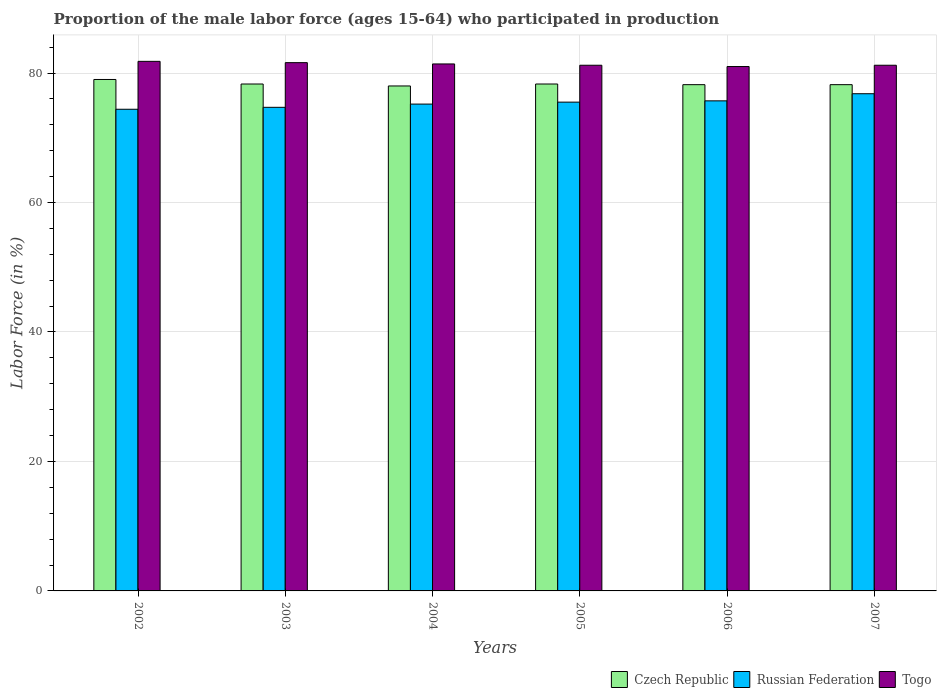How many different coloured bars are there?
Your answer should be compact. 3. Are the number of bars on each tick of the X-axis equal?
Offer a terse response. Yes. What is the label of the 3rd group of bars from the left?
Offer a very short reply. 2004. In how many cases, is the number of bars for a given year not equal to the number of legend labels?
Your answer should be very brief. 0. What is the proportion of the male labor force who participated in production in Russian Federation in 2005?
Provide a succinct answer. 75.5. Across all years, what is the maximum proportion of the male labor force who participated in production in Togo?
Offer a very short reply. 81.8. Across all years, what is the minimum proportion of the male labor force who participated in production in Russian Federation?
Keep it short and to the point. 74.4. In which year was the proportion of the male labor force who participated in production in Czech Republic minimum?
Make the answer very short. 2004. What is the total proportion of the male labor force who participated in production in Czech Republic in the graph?
Make the answer very short. 470. What is the difference between the proportion of the male labor force who participated in production in Togo in 2004 and that in 2006?
Ensure brevity in your answer.  0.4. What is the difference between the proportion of the male labor force who participated in production in Czech Republic in 2007 and the proportion of the male labor force who participated in production in Togo in 2002?
Your answer should be compact. -3.6. What is the average proportion of the male labor force who participated in production in Russian Federation per year?
Your response must be concise. 75.38. In the year 2007, what is the difference between the proportion of the male labor force who participated in production in Togo and proportion of the male labor force who participated in production in Czech Republic?
Keep it short and to the point. 3. In how many years, is the proportion of the male labor force who participated in production in Togo greater than 24 %?
Provide a short and direct response. 6. What is the ratio of the proportion of the male labor force who participated in production in Togo in 2002 to that in 2003?
Your response must be concise. 1. Is the proportion of the male labor force who participated in production in Togo in 2003 less than that in 2005?
Ensure brevity in your answer.  No. Is the difference between the proportion of the male labor force who participated in production in Togo in 2006 and 2007 greater than the difference between the proportion of the male labor force who participated in production in Czech Republic in 2006 and 2007?
Your answer should be compact. No. What is the difference between the highest and the second highest proportion of the male labor force who participated in production in Togo?
Your response must be concise. 0.2. What is the difference between the highest and the lowest proportion of the male labor force who participated in production in Russian Federation?
Your response must be concise. 2.4. In how many years, is the proportion of the male labor force who participated in production in Czech Republic greater than the average proportion of the male labor force who participated in production in Czech Republic taken over all years?
Your response must be concise. 1. What does the 2nd bar from the left in 2004 represents?
Your response must be concise. Russian Federation. What does the 1st bar from the right in 2004 represents?
Offer a terse response. Togo. How many bars are there?
Provide a succinct answer. 18. Are all the bars in the graph horizontal?
Give a very brief answer. No. How many years are there in the graph?
Offer a very short reply. 6. Are the values on the major ticks of Y-axis written in scientific E-notation?
Your response must be concise. No. Does the graph contain any zero values?
Your answer should be very brief. No. Does the graph contain grids?
Make the answer very short. Yes. What is the title of the graph?
Give a very brief answer. Proportion of the male labor force (ages 15-64) who participated in production. What is the Labor Force (in %) of Czech Republic in 2002?
Keep it short and to the point. 79. What is the Labor Force (in %) in Russian Federation in 2002?
Your answer should be compact. 74.4. What is the Labor Force (in %) of Togo in 2002?
Your answer should be very brief. 81.8. What is the Labor Force (in %) in Czech Republic in 2003?
Ensure brevity in your answer.  78.3. What is the Labor Force (in %) in Russian Federation in 2003?
Offer a very short reply. 74.7. What is the Labor Force (in %) of Togo in 2003?
Offer a terse response. 81.6. What is the Labor Force (in %) in Russian Federation in 2004?
Your response must be concise. 75.2. What is the Labor Force (in %) in Togo in 2004?
Provide a succinct answer. 81.4. What is the Labor Force (in %) of Czech Republic in 2005?
Your answer should be compact. 78.3. What is the Labor Force (in %) in Russian Federation in 2005?
Offer a very short reply. 75.5. What is the Labor Force (in %) in Togo in 2005?
Ensure brevity in your answer.  81.2. What is the Labor Force (in %) in Czech Republic in 2006?
Your response must be concise. 78.2. What is the Labor Force (in %) in Russian Federation in 2006?
Your answer should be very brief. 75.7. What is the Labor Force (in %) of Czech Republic in 2007?
Provide a succinct answer. 78.2. What is the Labor Force (in %) of Russian Federation in 2007?
Your answer should be very brief. 76.8. What is the Labor Force (in %) in Togo in 2007?
Your response must be concise. 81.2. Across all years, what is the maximum Labor Force (in %) in Czech Republic?
Your response must be concise. 79. Across all years, what is the maximum Labor Force (in %) in Russian Federation?
Provide a succinct answer. 76.8. Across all years, what is the maximum Labor Force (in %) in Togo?
Provide a short and direct response. 81.8. Across all years, what is the minimum Labor Force (in %) of Russian Federation?
Keep it short and to the point. 74.4. Across all years, what is the minimum Labor Force (in %) of Togo?
Keep it short and to the point. 81. What is the total Labor Force (in %) of Czech Republic in the graph?
Provide a short and direct response. 470. What is the total Labor Force (in %) in Russian Federation in the graph?
Make the answer very short. 452.3. What is the total Labor Force (in %) of Togo in the graph?
Your answer should be very brief. 488.2. What is the difference between the Labor Force (in %) of Togo in 2002 and that in 2003?
Provide a short and direct response. 0.2. What is the difference between the Labor Force (in %) of Czech Republic in 2002 and that in 2004?
Your answer should be compact. 1. What is the difference between the Labor Force (in %) in Togo in 2002 and that in 2004?
Make the answer very short. 0.4. What is the difference between the Labor Force (in %) of Russian Federation in 2002 and that in 2005?
Ensure brevity in your answer.  -1.1. What is the difference between the Labor Force (in %) of Togo in 2002 and that in 2005?
Provide a short and direct response. 0.6. What is the difference between the Labor Force (in %) of Czech Republic in 2002 and that in 2006?
Make the answer very short. 0.8. What is the difference between the Labor Force (in %) of Russian Federation in 2002 and that in 2007?
Your answer should be compact. -2.4. What is the difference between the Labor Force (in %) of Togo in 2002 and that in 2007?
Your answer should be compact. 0.6. What is the difference between the Labor Force (in %) in Czech Republic in 2003 and that in 2005?
Your answer should be very brief. 0. What is the difference between the Labor Force (in %) of Togo in 2003 and that in 2005?
Your answer should be compact. 0.4. What is the difference between the Labor Force (in %) in Togo in 2003 and that in 2006?
Offer a terse response. 0.6. What is the difference between the Labor Force (in %) in Czech Republic in 2003 and that in 2007?
Provide a succinct answer. 0.1. What is the difference between the Labor Force (in %) in Togo in 2004 and that in 2005?
Offer a terse response. 0.2. What is the difference between the Labor Force (in %) in Togo in 2004 and that in 2006?
Keep it short and to the point. 0.4. What is the difference between the Labor Force (in %) of Russian Federation in 2004 and that in 2007?
Give a very brief answer. -1.6. What is the difference between the Labor Force (in %) of Czech Republic in 2005 and that in 2006?
Offer a terse response. 0.1. What is the difference between the Labor Force (in %) in Russian Federation in 2005 and that in 2006?
Keep it short and to the point. -0.2. What is the difference between the Labor Force (in %) of Togo in 2005 and that in 2006?
Make the answer very short. 0.2. What is the difference between the Labor Force (in %) in Czech Republic in 2005 and that in 2007?
Provide a succinct answer. 0.1. What is the difference between the Labor Force (in %) in Russian Federation in 2005 and that in 2007?
Make the answer very short. -1.3. What is the difference between the Labor Force (in %) in Czech Republic in 2006 and that in 2007?
Provide a succinct answer. 0. What is the difference between the Labor Force (in %) of Russian Federation in 2006 and that in 2007?
Provide a short and direct response. -1.1. What is the difference between the Labor Force (in %) in Togo in 2006 and that in 2007?
Provide a succinct answer. -0.2. What is the difference between the Labor Force (in %) in Czech Republic in 2002 and the Labor Force (in %) in Russian Federation in 2003?
Offer a terse response. 4.3. What is the difference between the Labor Force (in %) in Czech Republic in 2002 and the Labor Force (in %) in Togo in 2003?
Offer a very short reply. -2.6. What is the difference between the Labor Force (in %) in Russian Federation in 2002 and the Labor Force (in %) in Togo in 2003?
Make the answer very short. -7.2. What is the difference between the Labor Force (in %) of Czech Republic in 2002 and the Labor Force (in %) of Russian Federation in 2004?
Make the answer very short. 3.8. What is the difference between the Labor Force (in %) of Russian Federation in 2002 and the Labor Force (in %) of Togo in 2007?
Give a very brief answer. -6.8. What is the difference between the Labor Force (in %) in Russian Federation in 2003 and the Labor Force (in %) in Togo in 2004?
Offer a terse response. -6.7. What is the difference between the Labor Force (in %) of Czech Republic in 2003 and the Labor Force (in %) of Togo in 2005?
Make the answer very short. -2.9. What is the difference between the Labor Force (in %) in Czech Republic in 2003 and the Labor Force (in %) in Russian Federation in 2006?
Offer a terse response. 2.6. What is the difference between the Labor Force (in %) of Russian Federation in 2003 and the Labor Force (in %) of Togo in 2006?
Your answer should be very brief. -6.3. What is the difference between the Labor Force (in %) in Czech Republic in 2003 and the Labor Force (in %) in Russian Federation in 2007?
Your response must be concise. 1.5. What is the difference between the Labor Force (in %) of Russian Federation in 2003 and the Labor Force (in %) of Togo in 2007?
Give a very brief answer. -6.5. What is the difference between the Labor Force (in %) in Czech Republic in 2004 and the Labor Force (in %) in Russian Federation in 2005?
Make the answer very short. 2.5. What is the difference between the Labor Force (in %) of Czech Republic in 2004 and the Labor Force (in %) of Russian Federation in 2006?
Your answer should be compact. 2.3. What is the difference between the Labor Force (in %) of Russian Federation in 2004 and the Labor Force (in %) of Togo in 2006?
Give a very brief answer. -5.8. What is the difference between the Labor Force (in %) of Czech Republic in 2004 and the Labor Force (in %) of Russian Federation in 2007?
Keep it short and to the point. 1.2. What is the difference between the Labor Force (in %) in Czech Republic in 2005 and the Labor Force (in %) in Togo in 2006?
Your response must be concise. -2.7. What is the difference between the Labor Force (in %) in Russian Federation in 2005 and the Labor Force (in %) in Togo in 2006?
Your answer should be very brief. -5.5. What is the difference between the Labor Force (in %) in Czech Republic in 2005 and the Labor Force (in %) in Russian Federation in 2007?
Offer a very short reply. 1.5. What is the difference between the Labor Force (in %) of Russian Federation in 2006 and the Labor Force (in %) of Togo in 2007?
Your response must be concise. -5.5. What is the average Labor Force (in %) of Czech Republic per year?
Your answer should be very brief. 78.33. What is the average Labor Force (in %) of Russian Federation per year?
Your answer should be compact. 75.38. What is the average Labor Force (in %) of Togo per year?
Offer a terse response. 81.37. In the year 2002, what is the difference between the Labor Force (in %) in Czech Republic and Labor Force (in %) in Russian Federation?
Provide a succinct answer. 4.6. In the year 2004, what is the difference between the Labor Force (in %) of Russian Federation and Labor Force (in %) of Togo?
Offer a very short reply. -6.2. In the year 2005, what is the difference between the Labor Force (in %) of Czech Republic and Labor Force (in %) of Russian Federation?
Provide a succinct answer. 2.8. In the year 2005, what is the difference between the Labor Force (in %) in Russian Federation and Labor Force (in %) in Togo?
Your answer should be very brief. -5.7. In the year 2006, what is the difference between the Labor Force (in %) in Czech Republic and Labor Force (in %) in Russian Federation?
Provide a short and direct response. 2.5. In the year 2007, what is the difference between the Labor Force (in %) in Czech Republic and Labor Force (in %) in Russian Federation?
Give a very brief answer. 1.4. In the year 2007, what is the difference between the Labor Force (in %) of Russian Federation and Labor Force (in %) of Togo?
Give a very brief answer. -4.4. What is the ratio of the Labor Force (in %) of Czech Republic in 2002 to that in 2003?
Offer a very short reply. 1.01. What is the ratio of the Labor Force (in %) of Czech Republic in 2002 to that in 2004?
Make the answer very short. 1.01. What is the ratio of the Labor Force (in %) in Russian Federation in 2002 to that in 2004?
Keep it short and to the point. 0.99. What is the ratio of the Labor Force (in %) in Togo in 2002 to that in 2004?
Offer a very short reply. 1. What is the ratio of the Labor Force (in %) of Czech Republic in 2002 to that in 2005?
Offer a terse response. 1.01. What is the ratio of the Labor Force (in %) in Russian Federation in 2002 to that in 2005?
Provide a succinct answer. 0.99. What is the ratio of the Labor Force (in %) of Togo in 2002 to that in 2005?
Ensure brevity in your answer.  1.01. What is the ratio of the Labor Force (in %) in Czech Republic in 2002 to that in 2006?
Your answer should be compact. 1.01. What is the ratio of the Labor Force (in %) in Russian Federation in 2002 to that in 2006?
Your answer should be compact. 0.98. What is the ratio of the Labor Force (in %) of Togo in 2002 to that in 2006?
Offer a very short reply. 1.01. What is the ratio of the Labor Force (in %) of Czech Republic in 2002 to that in 2007?
Your answer should be very brief. 1.01. What is the ratio of the Labor Force (in %) of Russian Federation in 2002 to that in 2007?
Provide a succinct answer. 0.97. What is the ratio of the Labor Force (in %) of Togo in 2002 to that in 2007?
Your answer should be compact. 1.01. What is the ratio of the Labor Force (in %) of Czech Republic in 2003 to that in 2004?
Offer a terse response. 1. What is the ratio of the Labor Force (in %) of Togo in 2003 to that in 2004?
Provide a succinct answer. 1. What is the ratio of the Labor Force (in %) in Czech Republic in 2003 to that in 2005?
Ensure brevity in your answer.  1. What is the ratio of the Labor Force (in %) in Togo in 2003 to that in 2005?
Make the answer very short. 1. What is the ratio of the Labor Force (in %) of Togo in 2003 to that in 2006?
Offer a terse response. 1.01. What is the ratio of the Labor Force (in %) in Russian Federation in 2003 to that in 2007?
Keep it short and to the point. 0.97. What is the ratio of the Labor Force (in %) in Togo in 2003 to that in 2007?
Your answer should be compact. 1. What is the ratio of the Labor Force (in %) of Czech Republic in 2004 to that in 2005?
Your response must be concise. 1. What is the ratio of the Labor Force (in %) in Russian Federation in 2004 to that in 2006?
Your response must be concise. 0.99. What is the ratio of the Labor Force (in %) in Czech Republic in 2004 to that in 2007?
Make the answer very short. 1. What is the ratio of the Labor Force (in %) of Russian Federation in 2004 to that in 2007?
Your answer should be very brief. 0.98. What is the ratio of the Labor Force (in %) in Togo in 2004 to that in 2007?
Your response must be concise. 1. What is the ratio of the Labor Force (in %) in Czech Republic in 2005 to that in 2006?
Your answer should be compact. 1. What is the ratio of the Labor Force (in %) in Togo in 2005 to that in 2006?
Provide a succinct answer. 1. What is the ratio of the Labor Force (in %) of Czech Republic in 2005 to that in 2007?
Give a very brief answer. 1. What is the ratio of the Labor Force (in %) in Russian Federation in 2005 to that in 2007?
Your response must be concise. 0.98. What is the ratio of the Labor Force (in %) of Togo in 2005 to that in 2007?
Offer a terse response. 1. What is the ratio of the Labor Force (in %) of Russian Federation in 2006 to that in 2007?
Provide a short and direct response. 0.99. What is the difference between the highest and the second highest Labor Force (in %) in Russian Federation?
Keep it short and to the point. 1.1. What is the difference between the highest and the second highest Labor Force (in %) in Togo?
Your answer should be very brief. 0.2. What is the difference between the highest and the lowest Labor Force (in %) in Russian Federation?
Keep it short and to the point. 2.4. 